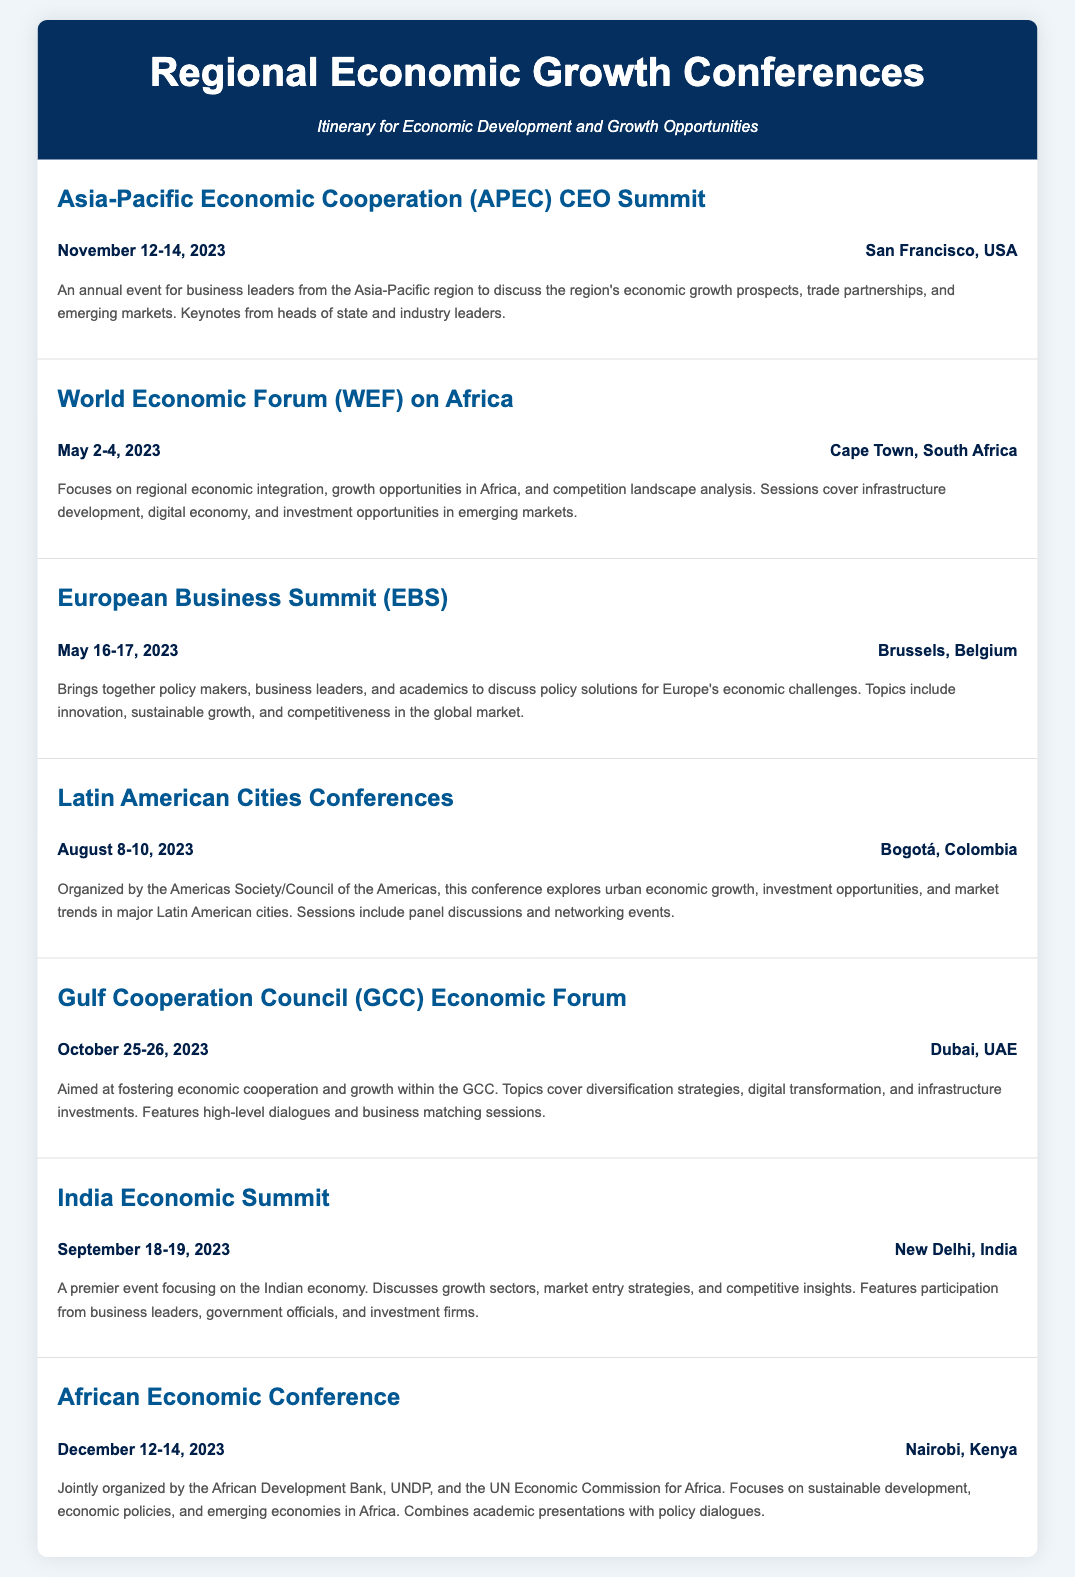What is the date of the APEC CEO Summit? The APEC CEO Summit is scheduled for November 12-14, 2023, as stated in the event details.
Answer: November 12-14, 2023 Where is the World Economic Forum on Africa held? The location of the World Economic Forum on Africa is specified as Cape Town, South Africa.
Answer: Cape Town, South Africa Which conference focuses on urban economic growth in Latin America? The Latin American Cities Conferences specifically addresses urban economic growth, as mentioned in the document.
Answer: Latin American Cities Conferences What is a major topic at the GCC Economic Forum? The document highlights diversification strategies as a key topic at the GCC Economic Forum.
Answer: Diversification strategies How many conferences take place in 2023 according to the itinerary? The itinerary lists a total of six conferences occurring in 2023.
Answer: Six Which organization is associated with the African Economic Conference? The African Development Bank is one of the organizations that jointly organizes the African Economic Conference.
Answer: African Development Bank What city hosts the India Economic Summit? New Delhi, India is indicated as the host city for the India Economic Summit in the itinerary.
Answer: New Delhi, India What is the focus of the European Business Summit? The focus of the European Business Summit is on policy solutions for Europe's economic challenges as outlined in the document.
Answer: Policy solutions for Europe's economic challenges 